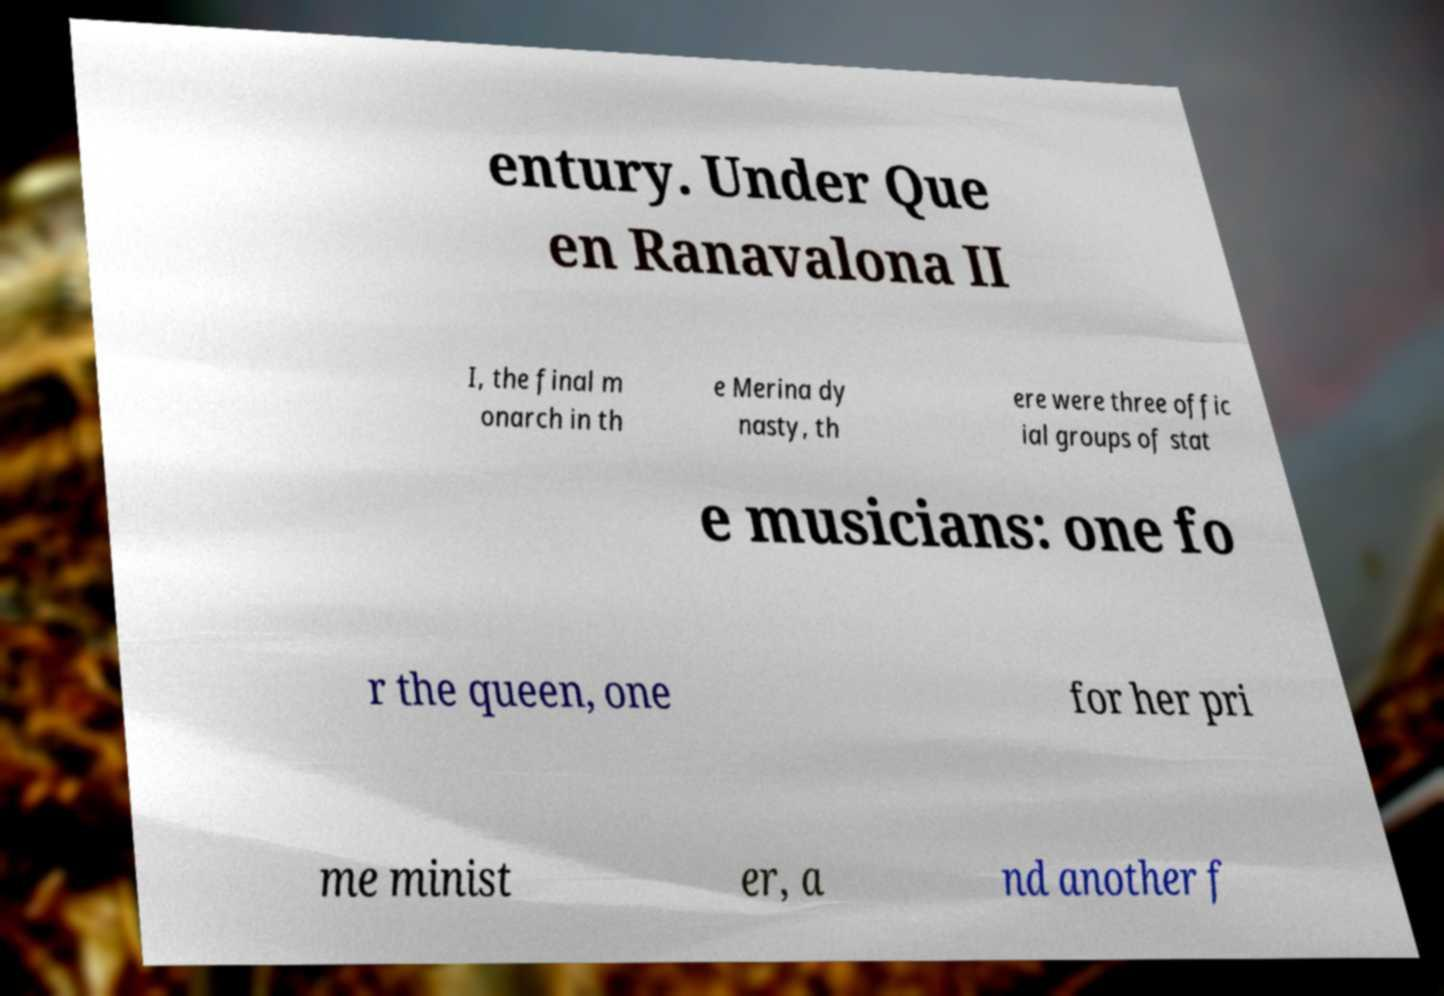Please read and relay the text visible in this image. What does it say? entury. Under Que en Ranavalona II I, the final m onarch in th e Merina dy nasty, th ere were three offic ial groups of stat e musicians: one fo r the queen, one for her pri me minist er, a nd another f 